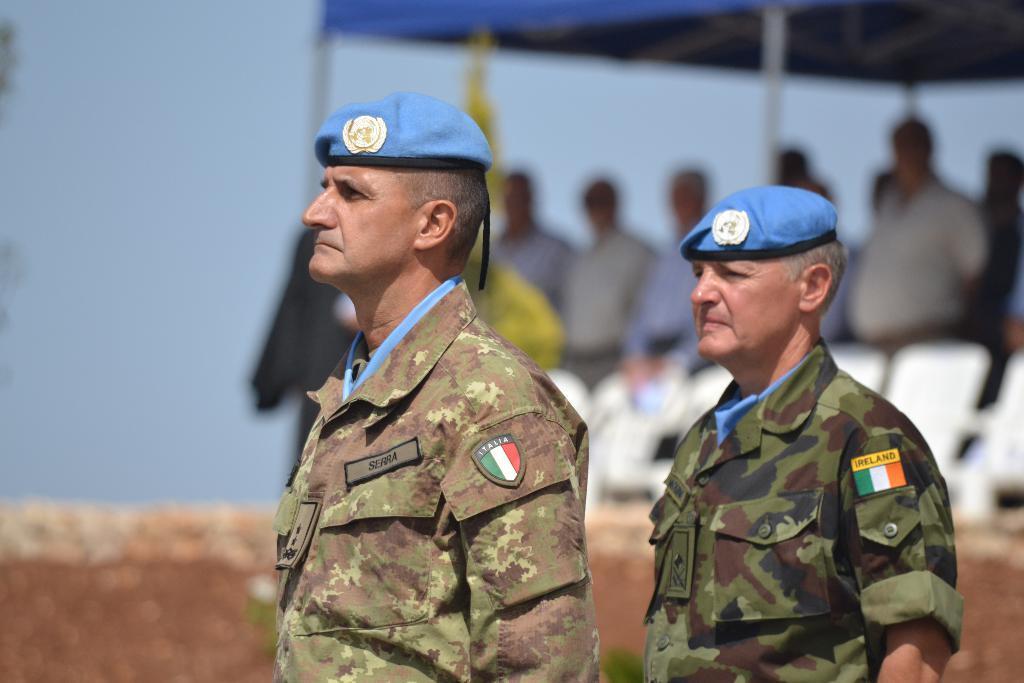Can you describe this image briefly? This picture is clicked outside. In the foreground we can see the two persons wearing uniforms and standing. In the background we can see the white color chairs and group of persons standing under the tent and we can see the sky. 